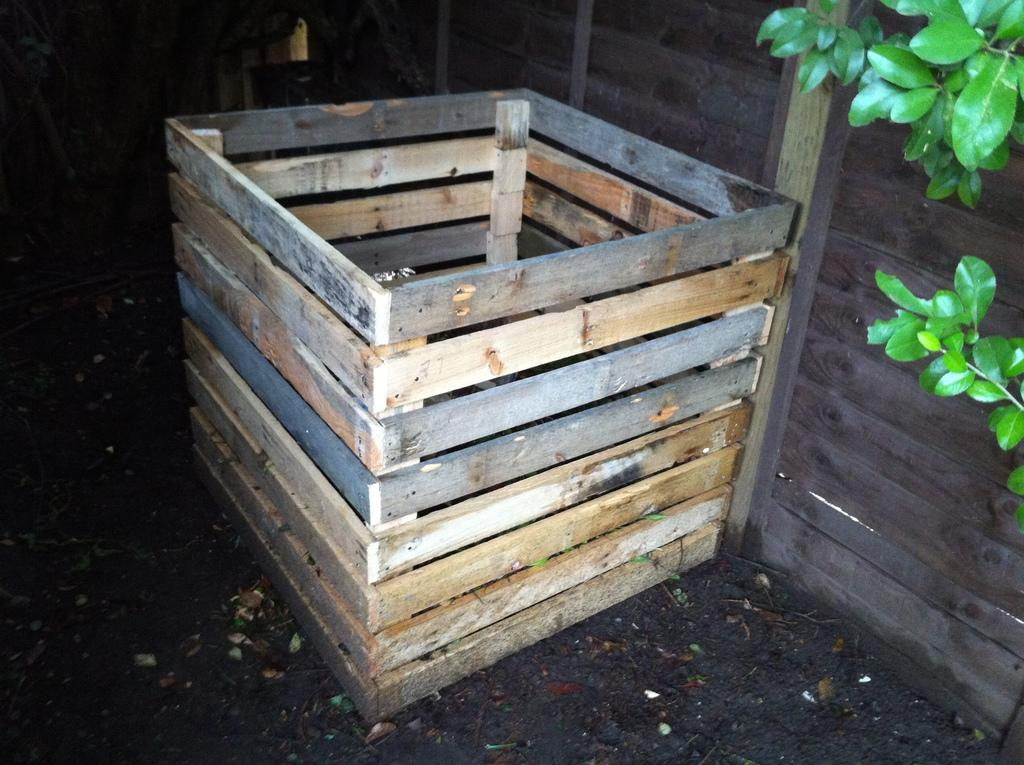What is the main object in the center of the image? There is a wooden box in the center of the image. What type of vegetation can be seen on the right side of the image? There are leaves on the right side of the image. What can be seen in the background of the image? There is a wall in the background of the image. What is present on the ground in the image? There are dry leaves on the ground in the image. What type of wool is visible in the image? There is no wool present in the image. 